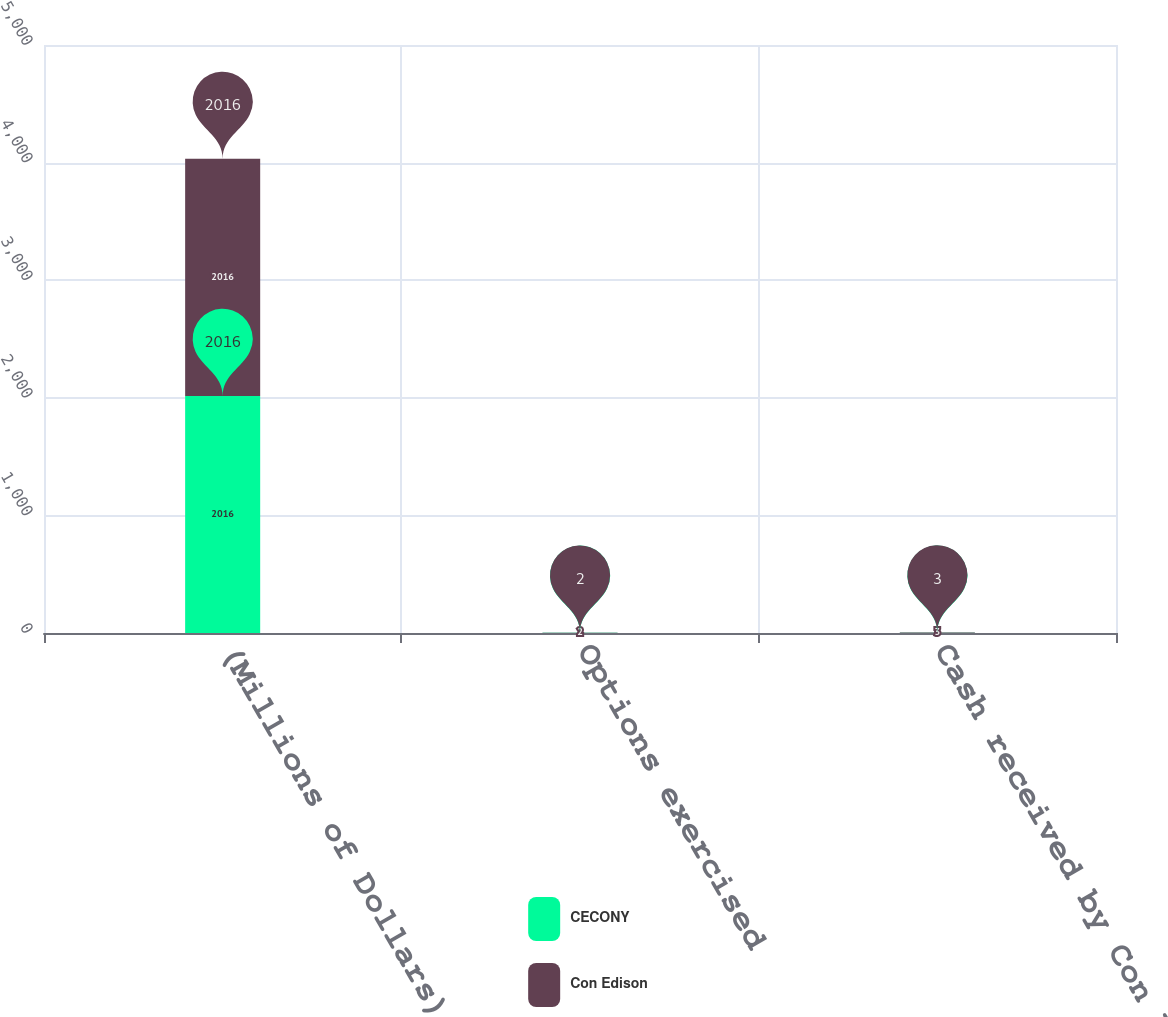<chart> <loc_0><loc_0><loc_500><loc_500><stacked_bar_chart><ecel><fcel>(Millions of Dollars)<fcel>Options exercised<fcel>Cash received by Con Edison<nl><fcel>CECONY<fcel>2016<fcel>2<fcel>3<nl><fcel>Con Edison<fcel>2016<fcel>2<fcel>3<nl></chart> 